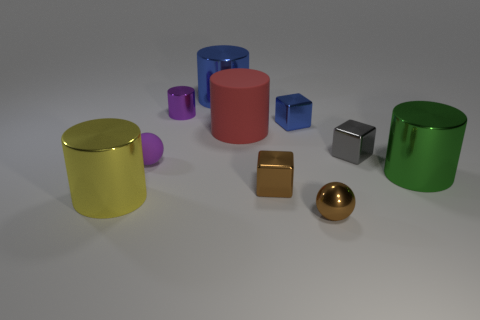Subtract all big rubber cylinders. How many cylinders are left? 4 Subtract all blue cubes. How many cubes are left? 2 Subtract 2 cylinders. How many cylinders are left? 3 Subtract all cubes. How many objects are left? 7 Add 9 small gray shiny cubes. How many small gray shiny cubes exist? 10 Subtract 0 cyan blocks. How many objects are left? 10 Subtract all cyan balls. Subtract all gray cubes. How many balls are left? 2 Subtract all gray blocks. How many brown balls are left? 1 Subtract all blue cylinders. Subtract all large cylinders. How many objects are left? 5 Add 5 tiny blue metallic things. How many tiny blue metallic things are left? 6 